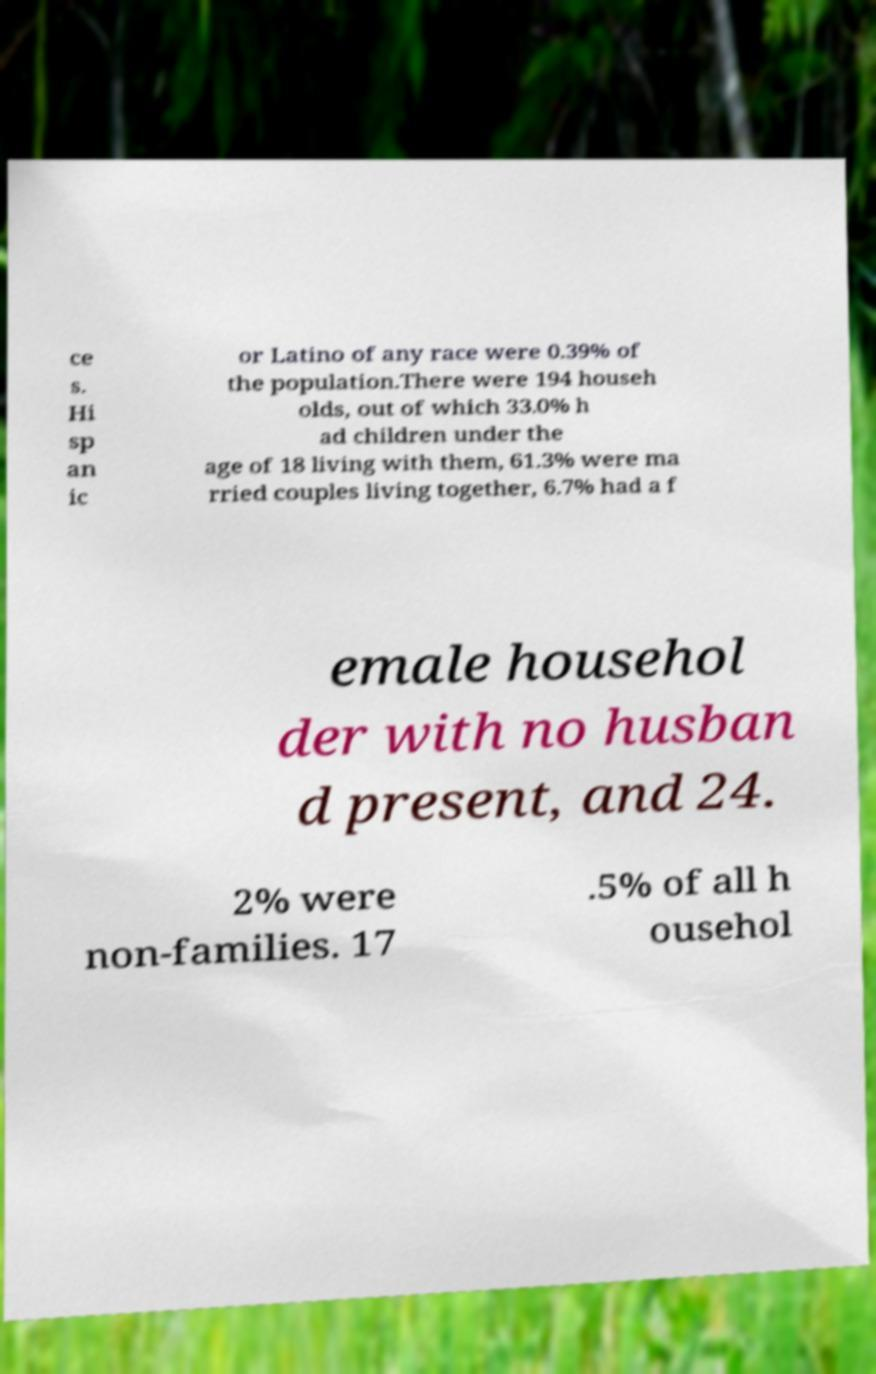I need the written content from this picture converted into text. Can you do that? ce s. Hi sp an ic or Latino of any race were 0.39% of the population.There were 194 househ olds, out of which 33.0% h ad children under the age of 18 living with them, 61.3% were ma rried couples living together, 6.7% had a f emale househol der with no husban d present, and 24. 2% were non-families. 17 .5% of all h ousehol 